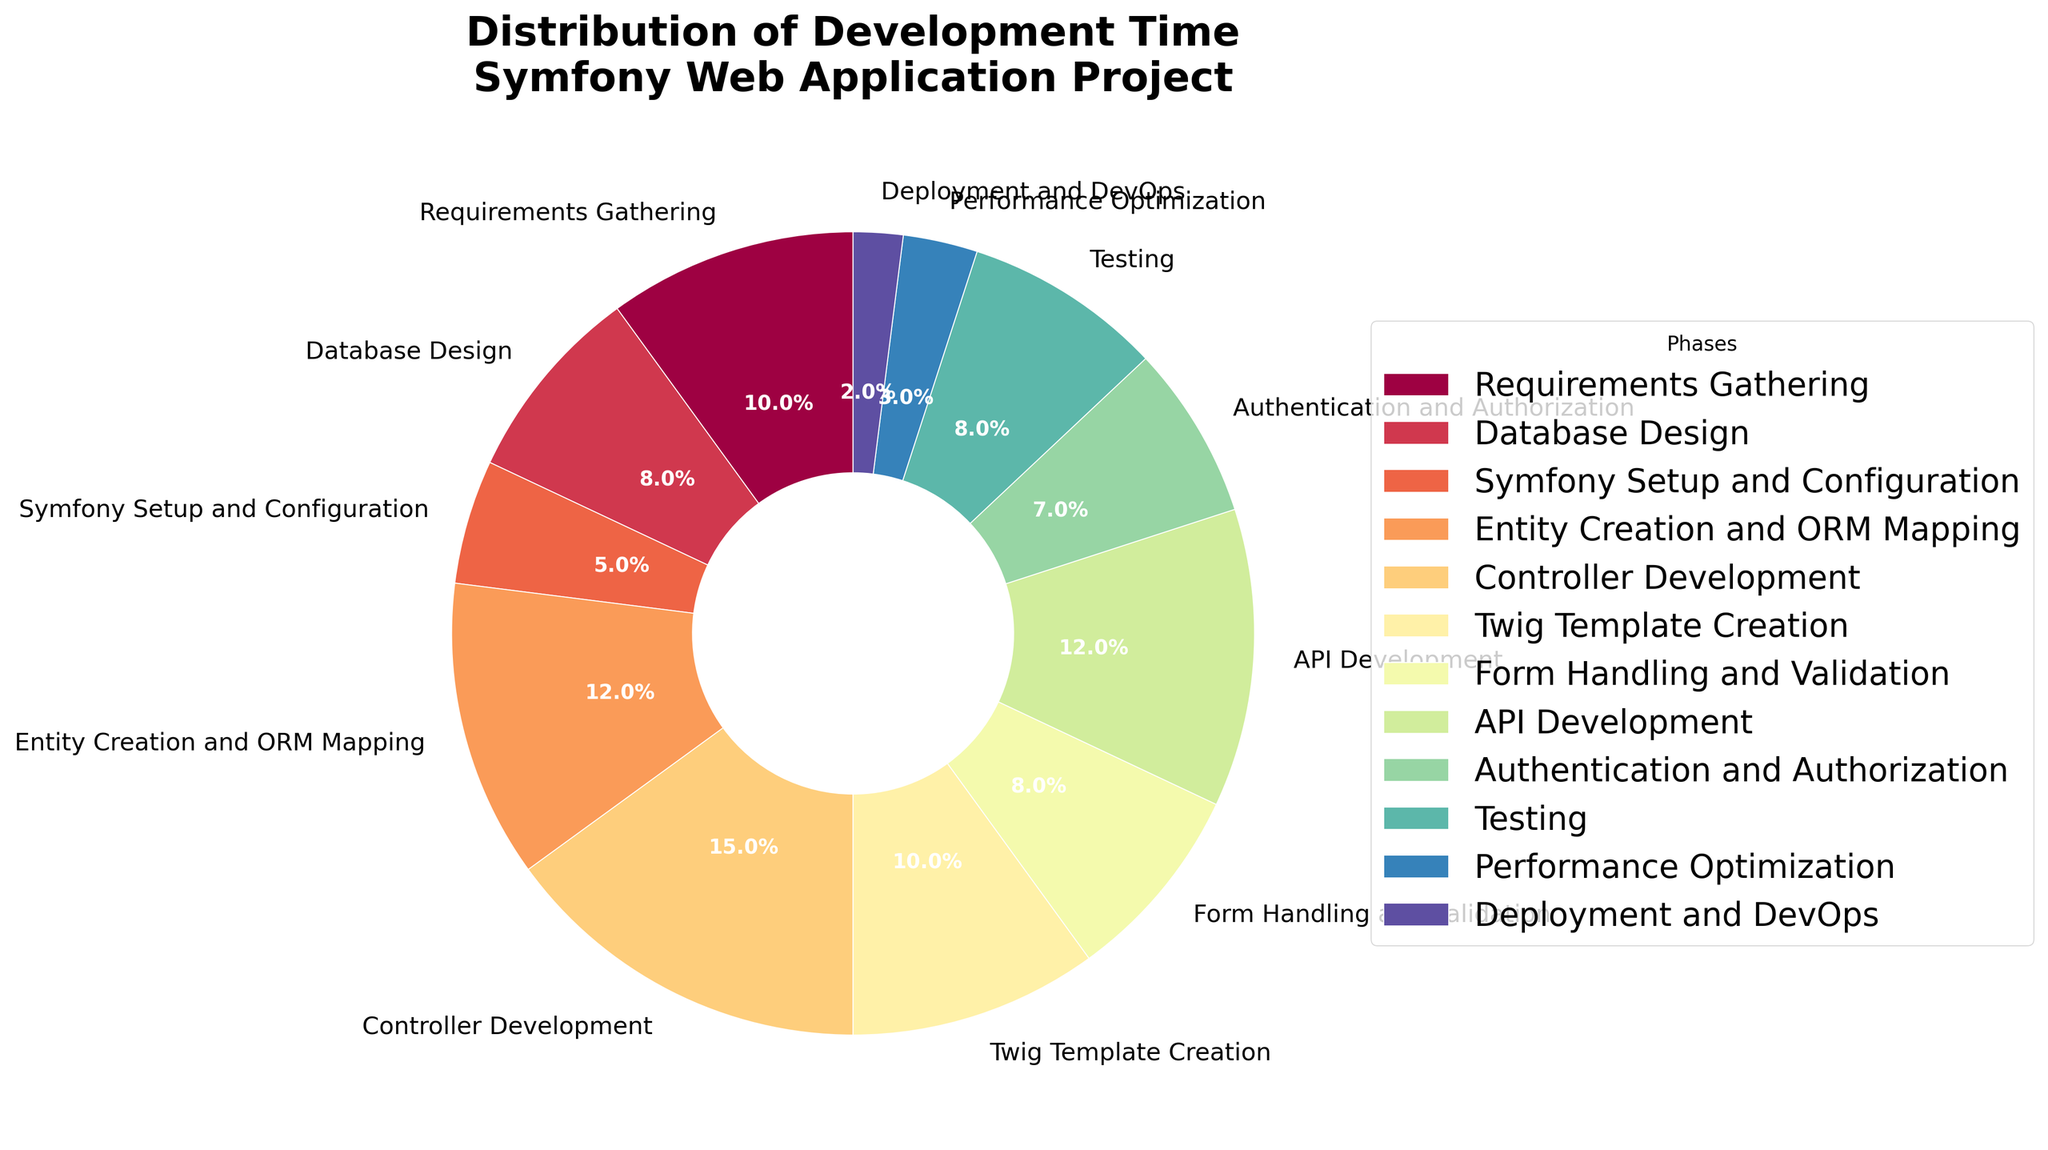What phase takes up the highest percentage of development time? Controller Development occupies the largest wedge in the pie chart, indicating it takes the highest percentage of the development time.
Answer: Controller Development Which phases combined take up more development time: Entity Creation and ORM Mapping, or Twig Template Creation and Form Handling and Validation? Adding Entity Creation and ORM Mapping (12%) with API Development (12%) gives 24%. Twig Template Creation is 10%, and Form Handling and Validation is 8%, giving 18%. Comparing 24% and 18%, Entity Creation and ORM Mapping along with API Development take more time.
Answer: Entity Creation and ORM Mapping with API Development Which phase has a higher percentage: Testing or Authentication and Authorization? By comparing the sizes of the wedges, Testing is 8% and Authentication and Authorization is 7%. Testing has a higher percentage.
Answer: Testing What percentage of development time is spent on Testing and Performance Optimization combined? Testing takes 8% while Performance Optimization takes 3%. Adding them together, 8% + 3% = 11%.
Answer: 11% What color is used for Symfony Setup and Configuration phase? The wedge representing Symfony Setup and Configuration is colored (look for the code associated color, such as "a light purple hue").
Answer: (Describe the actual color seen in the chart, e.g., purple if it's visual) Which is smaller: the percentage for Deployment and DevOps, or the combined percentage for Symfony Setup and Configuration and Authentication and Authorization? Deployment and DevOps is 2%. Symfony Setup and Configuration is 5%, Authentication and Authorization is 7%; combined these make 12%. Comparing 2% and 12%, Deployment and DevOps is smaller.
Answer: Deployment and DevOps Compare the sum of percentages for Requirements Gathering and Database Design to the percentage for Controller Development. Requirements Gathering is 10% and Database Design is 8%, giving 10% + 8% = 18%. Controller Development is 15%. Comparing 18% and 15%, the sum of Requirements Gathering and Database Design is greater.
Answer: Sum of Requirements Gathering and Database Design Name three phases with the smallest allocation of development time. The phases with the smallest percentages are Deployment and DevOps (2%), Performance Optimization (3%), and Symfony Setup and Configuration (5%).
Answer: Deployment and DevOps, Performance Optimization, Symfony Setup and Configuration 